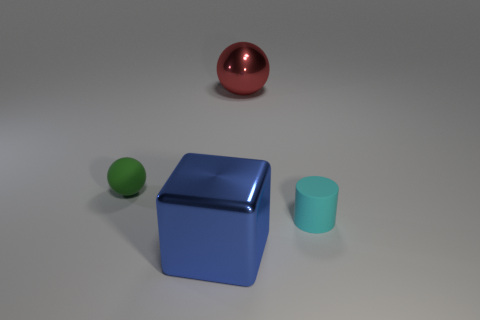There is a red metallic object; is it the same shape as the tiny matte object that is left of the cyan cylinder?
Your answer should be very brief. Yes. Do the metallic object that is in front of the green sphere and the small object left of the tiny rubber cylinder have the same color?
Give a very brief answer. No. Are any big cyan blocks visible?
Provide a succinct answer. No. Is there a red ball that has the same material as the big blue object?
Ensure brevity in your answer.  Yes. What color is the large cube?
Make the answer very short. Blue. The block that is the same size as the red ball is what color?
Offer a terse response. Blue. How many matte objects are either blue objects or small spheres?
Keep it short and to the point. 1. What number of objects are right of the big blue shiny object and in front of the red metal thing?
Make the answer very short. 1. Is there anything else that has the same shape as the red shiny object?
Your answer should be compact. Yes. What number of other things are there of the same size as the shiny sphere?
Your response must be concise. 1. 